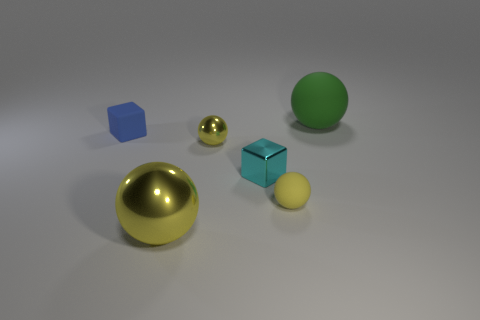Subtract all green spheres. How many spheres are left? 3 Subtract 0 green cylinders. How many objects are left? 6 Subtract all cubes. How many objects are left? 4 Subtract 1 spheres. How many spheres are left? 3 Subtract all brown balls. Subtract all yellow cubes. How many balls are left? 4 Subtract all cyan cylinders. How many gray blocks are left? 0 Subtract all tiny rubber things. Subtract all large green metal things. How many objects are left? 4 Add 2 small blue matte blocks. How many small blue matte blocks are left? 3 Add 6 matte blocks. How many matte blocks exist? 7 Add 1 spheres. How many objects exist? 7 